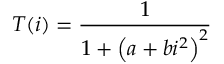Convert formula to latex. <formula><loc_0><loc_0><loc_500><loc_500>T ( i ) = \frac { 1 } { 1 + \left ( a + b i ^ { 2 } \right ) ^ { 2 } }</formula> 